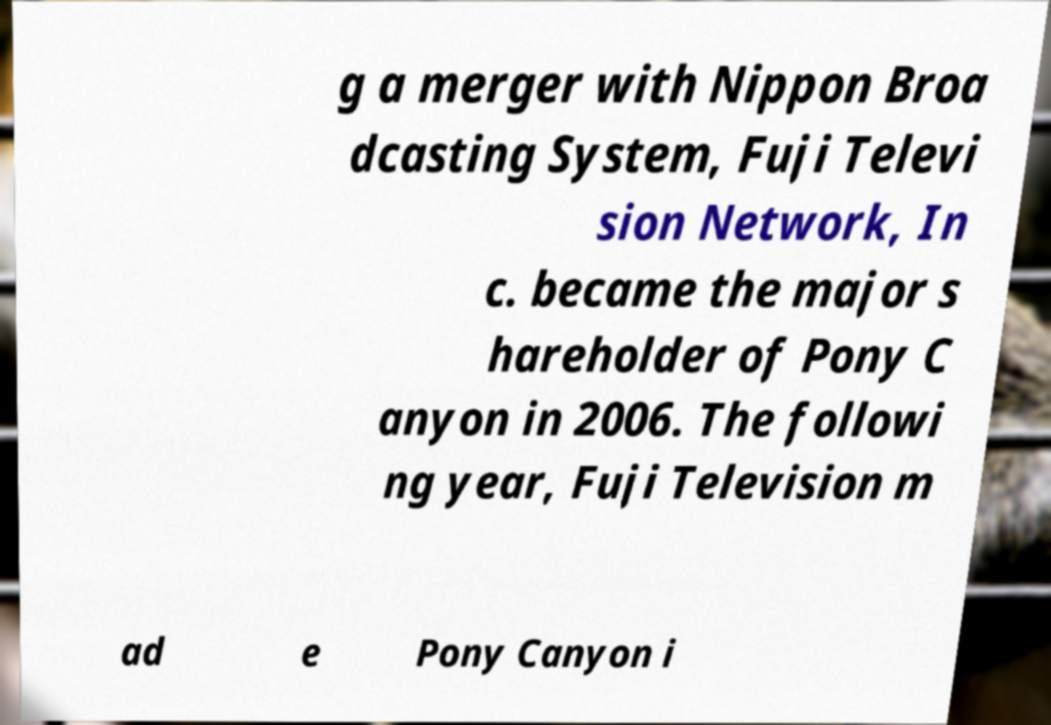Could you extract and type out the text from this image? g a merger with Nippon Broa dcasting System, Fuji Televi sion Network, In c. became the major s hareholder of Pony C anyon in 2006. The followi ng year, Fuji Television m ad e Pony Canyon i 